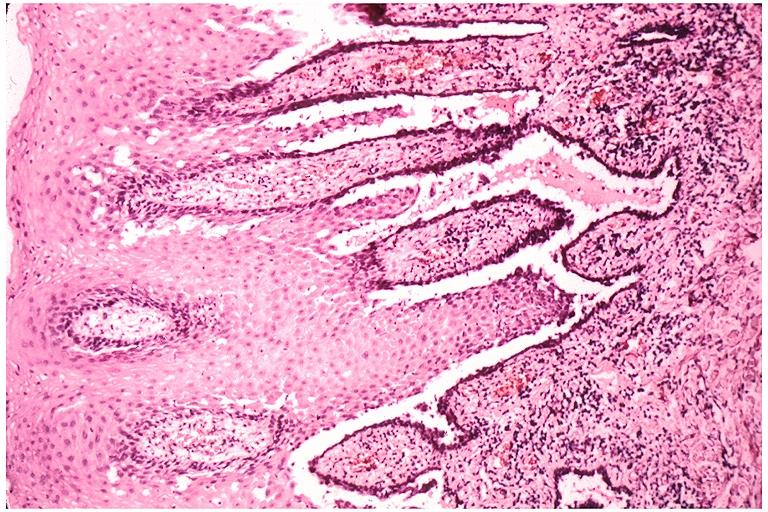s umbilical cord present?
Answer the question using a single word or phrase. No 